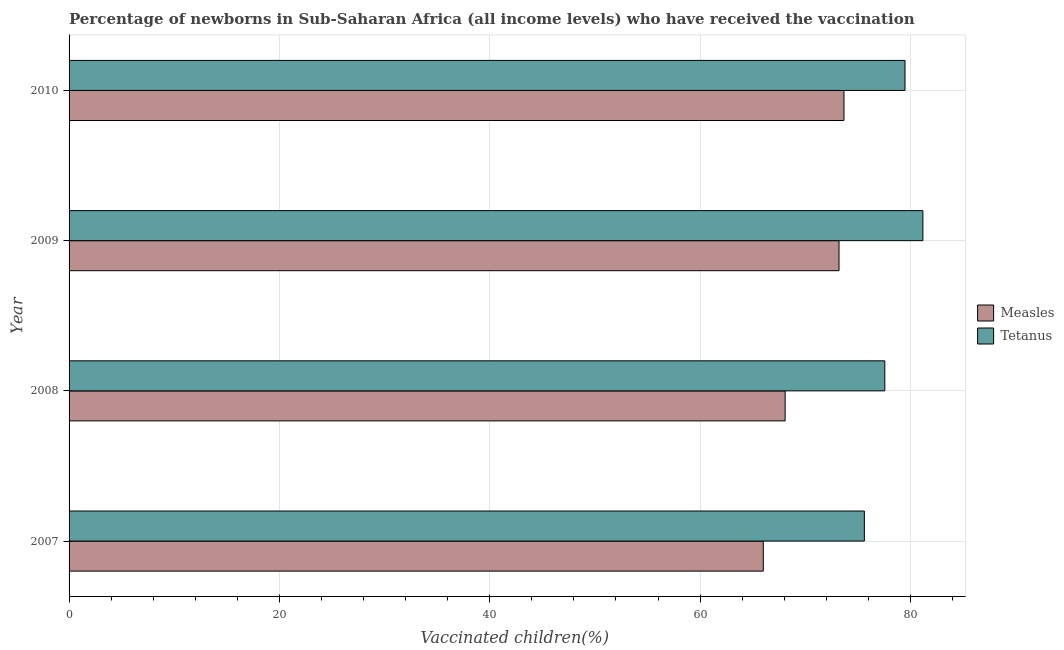How many different coloured bars are there?
Your answer should be compact. 2. Are the number of bars per tick equal to the number of legend labels?
Keep it short and to the point. Yes. Are the number of bars on each tick of the Y-axis equal?
Ensure brevity in your answer.  Yes. How many bars are there on the 4th tick from the bottom?
Offer a terse response. 2. What is the percentage of newborns who received vaccination for measles in 2008?
Your answer should be very brief. 68.08. Across all years, what is the maximum percentage of newborns who received vaccination for tetanus?
Ensure brevity in your answer.  81.18. Across all years, what is the minimum percentage of newborns who received vaccination for tetanus?
Ensure brevity in your answer.  75.62. In which year was the percentage of newborns who received vaccination for tetanus minimum?
Offer a very short reply. 2007. What is the total percentage of newborns who received vaccination for measles in the graph?
Offer a terse response. 280.97. What is the difference between the percentage of newborns who received vaccination for measles in 2008 and that in 2010?
Offer a terse response. -5.59. What is the difference between the percentage of newborns who received vaccination for tetanus in 2007 and the percentage of newborns who received vaccination for measles in 2010?
Your response must be concise. 1.94. What is the average percentage of newborns who received vaccination for measles per year?
Your answer should be very brief. 70.24. In the year 2010, what is the difference between the percentage of newborns who received vaccination for measles and percentage of newborns who received vaccination for tetanus?
Your response must be concise. -5.8. In how many years, is the percentage of newborns who received vaccination for measles greater than 64 %?
Give a very brief answer. 4. Is the difference between the percentage of newborns who received vaccination for tetanus in 2007 and 2010 greater than the difference between the percentage of newborns who received vaccination for measles in 2007 and 2010?
Your answer should be very brief. Yes. What is the difference between the highest and the second highest percentage of newborns who received vaccination for tetanus?
Ensure brevity in your answer.  1.7. What is the difference between the highest and the lowest percentage of newborns who received vaccination for tetanus?
Provide a succinct answer. 5.57. In how many years, is the percentage of newborns who received vaccination for tetanus greater than the average percentage of newborns who received vaccination for tetanus taken over all years?
Provide a succinct answer. 2. Is the sum of the percentage of newborns who received vaccination for measles in 2008 and 2009 greater than the maximum percentage of newborns who received vaccination for tetanus across all years?
Your answer should be compact. Yes. What does the 1st bar from the top in 2009 represents?
Keep it short and to the point. Tetanus. What does the 1st bar from the bottom in 2007 represents?
Offer a very short reply. Measles. What is the difference between two consecutive major ticks on the X-axis?
Your answer should be very brief. 20. Are the values on the major ticks of X-axis written in scientific E-notation?
Provide a succinct answer. No. Does the graph contain any zero values?
Provide a succinct answer. No. Does the graph contain grids?
Ensure brevity in your answer.  Yes. How many legend labels are there?
Provide a succinct answer. 2. What is the title of the graph?
Offer a very short reply. Percentage of newborns in Sub-Saharan Africa (all income levels) who have received the vaccination. What is the label or title of the X-axis?
Offer a terse response. Vaccinated children(%)
. What is the Vaccinated children(%)
 of Measles in 2007?
Offer a terse response. 66.01. What is the Vaccinated children(%)
 of Tetanus in 2007?
Your response must be concise. 75.62. What is the Vaccinated children(%)
 of Measles in 2008?
Your answer should be very brief. 68.08. What is the Vaccinated children(%)
 of Tetanus in 2008?
Offer a very short reply. 77.56. What is the Vaccinated children(%)
 of Measles in 2009?
Your response must be concise. 73.21. What is the Vaccinated children(%)
 in Tetanus in 2009?
Ensure brevity in your answer.  81.18. What is the Vaccinated children(%)
 of Measles in 2010?
Your answer should be very brief. 73.68. What is the Vaccinated children(%)
 of Tetanus in 2010?
Offer a terse response. 79.48. Across all years, what is the maximum Vaccinated children(%)
 of Measles?
Your answer should be compact. 73.68. Across all years, what is the maximum Vaccinated children(%)
 in Tetanus?
Your response must be concise. 81.18. Across all years, what is the minimum Vaccinated children(%)
 in Measles?
Give a very brief answer. 66.01. Across all years, what is the minimum Vaccinated children(%)
 in Tetanus?
Keep it short and to the point. 75.62. What is the total Vaccinated children(%)
 in Measles in the graph?
Give a very brief answer. 280.97. What is the total Vaccinated children(%)
 in Tetanus in the graph?
Make the answer very short. 313.84. What is the difference between the Vaccinated children(%)
 of Measles in 2007 and that in 2008?
Provide a short and direct response. -2.08. What is the difference between the Vaccinated children(%)
 of Tetanus in 2007 and that in 2008?
Offer a terse response. -1.95. What is the difference between the Vaccinated children(%)
 in Measles in 2007 and that in 2009?
Make the answer very short. -7.2. What is the difference between the Vaccinated children(%)
 in Tetanus in 2007 and that in 2009?
Offer a terse response. -5.57. What is the difference between the Vaccinated children(%)
 of Measles in 2007 and that in 2010?
Provide a short and direct response. -7.67. What is the difference between the Vaccinated children(%)
 of Tetanus in 2007 and that in 2010?
Your answer should be compact. -3.87. What is the difference between the Vaccinated children(%)
 of Measles in 2008 and that in 2009?
Offer a terse response. -5.12. What is the difference between the Vaccinated children(%)
 in Tetanus in 2008 and that in 2009?
Provide a succinct answer. -3.62. What is the difference between the Vaccinated children(%)
 of Measles in 2008 and that in 2010?
Ensure brevity in your answer.  -5.59. What is the difference between the Vaccinated children(%)
 of Tetanus in 2008 and that in 2010?
Offer a terse response. -1.92. What is the difference between the Vaccinated children(%)
 in Measles in 2009 and that in 2010?
Make the answer very short. -0.47. What is the difference between the Vaccinated children(%)
 in Tetanus in 2009 and that in 2010?
Offer a very short reply. 1.7. What is the difference between the Vaccinated children(%)
 in Measles in 2007 and the Vaccinated children(%)
 in Tetanus in 2008?
Provide a short and direct response. -11.55. What is the difference between the Vaccinated children(%)
 of Measles in 2007 and the Vaccinated children(%)
 of Tetanus in 2009?
Your answer should be compact. -15.18. What is the difference between the Vaccinated children(%)
 of Measles in 2007 and the Vaccinated children(%)
 of Tetanus in 2010?
Your response must be concise. -13.47. What is the difference between the Vaccinated children(%)
 of Measles in 2008 and the Vaccinated children(%)
 of Tetanus in 2009?
Provide a short and direct response. -13.1. What is the difference between the Vaccinated children(%)
 of Measles in 2008 and the Vaccinated children(%)
 of Tetanus in 2010?
Ensure brevity in your answer.  -11.4. What is the difference between the Vaccinated children(%)
 of Measles in 2009 and the Vaccinated children(%)
 of Tetanus in 2010?
Provide a succinct answer. -6.27. What is the average Vaccinated children(%)
 in Measles per year?
Your response must be concise. 70.24. What is the average Vaccinated children(%)
 in Tetanus per year?
Provide a succinct answer. 78.46. In the year 2007, what is the difference between the Vaccinated children(%)
 in Measles and Vaccinated children(%)
 in Tetanus?
Ensure brevity in your answer.  -9.61. In the year 2008, what is the difference between the Vaccinated children(%)
 in Measles and Vaccinated children(%)
 in Tetanus?
Provide a short and direct response. -9.48. In the year 2009, what is the difference between the Vaccinated children(%)
 of Measles and Vaccinated children(%)
 of Tetanus?
Offer a very short reply. -7.98. In the year 2010, what is the difference between the Vaccinated children(%)
 of Measles and Vaccinated children(%)
 of Tetanus?
Give a very brief answer. -5.8. What is the ratio of the Vaccinated children(%)
 of Measles in 2007 to that in 2008?
Give a very brief answer. 0.97. What is the ratio of the Vaccinated children(%)
 in Tetanus in 2007 to that in 2008?
Offer a very short reply. 0.97. What is the ratio of the Vaccinated children(%)
 in Measles in 2007 to that in 2009?
Your response must be concise. 0.9. What is the ratio of the Vaccinated children(%)
 in Tetanus in 2007 to that in 2009?
Keep it short and to the point. 0.93. What is the ratio of the Vaccinated children(%)
 in Measles in 2007 to that in 2010?
Your answer should be compact. 0.9. What is the ratio of the Vaccinated children(%)
 in Tetanus in 2007 to that in 2010?
Your answer should be compact. 0.95. What is the ratio of the Vaccinated children(%)
 of Tetanus in 2008 to that in 2009?
Your answer should be very brief. 0.96. What is the ratio of the Vaccinated children(%)
 in Measles in 2008 to that in 2010?
Offer a very short reply. 0.92. What is the ratio of the Vaccinated children(%)
 in Tetanus in 2008 to that in 2010?
Your response must be concise. 0.98. What is the ratio of the Vaccinated children(%)
 of Tetanus in 2009 to that in 2010?
Your response must be concise. 1.02. What is the difference between the highest and the second highest Vaccinated children(%)
 in Measles?
Keep it short and to the point. 0.47. What is the difference between the highest and the second highest Vaccinated children(%)
 in Tetanus?
Offer a very short reply. 1.7. What is the difference between the highest and the lowest Vaccinated children(%)
 of Measles?
Keep it short and to the point. 7.67. What is the difference between the highest and the lowest Vaccinated children(%)
 of Tetanus?
Your answer should be compact. 5.57. 